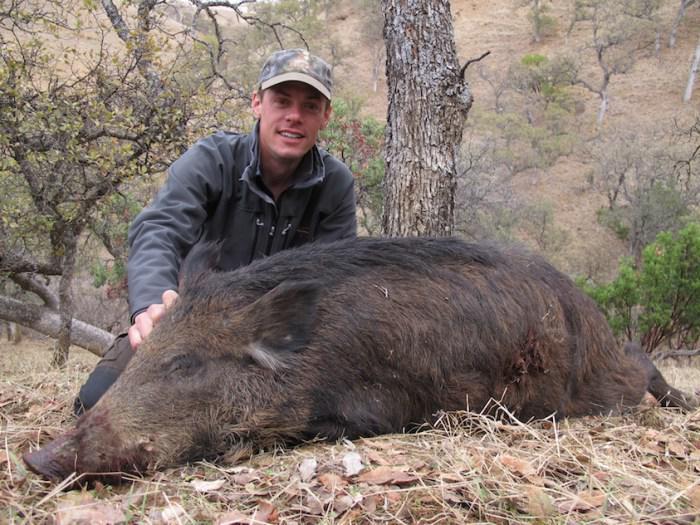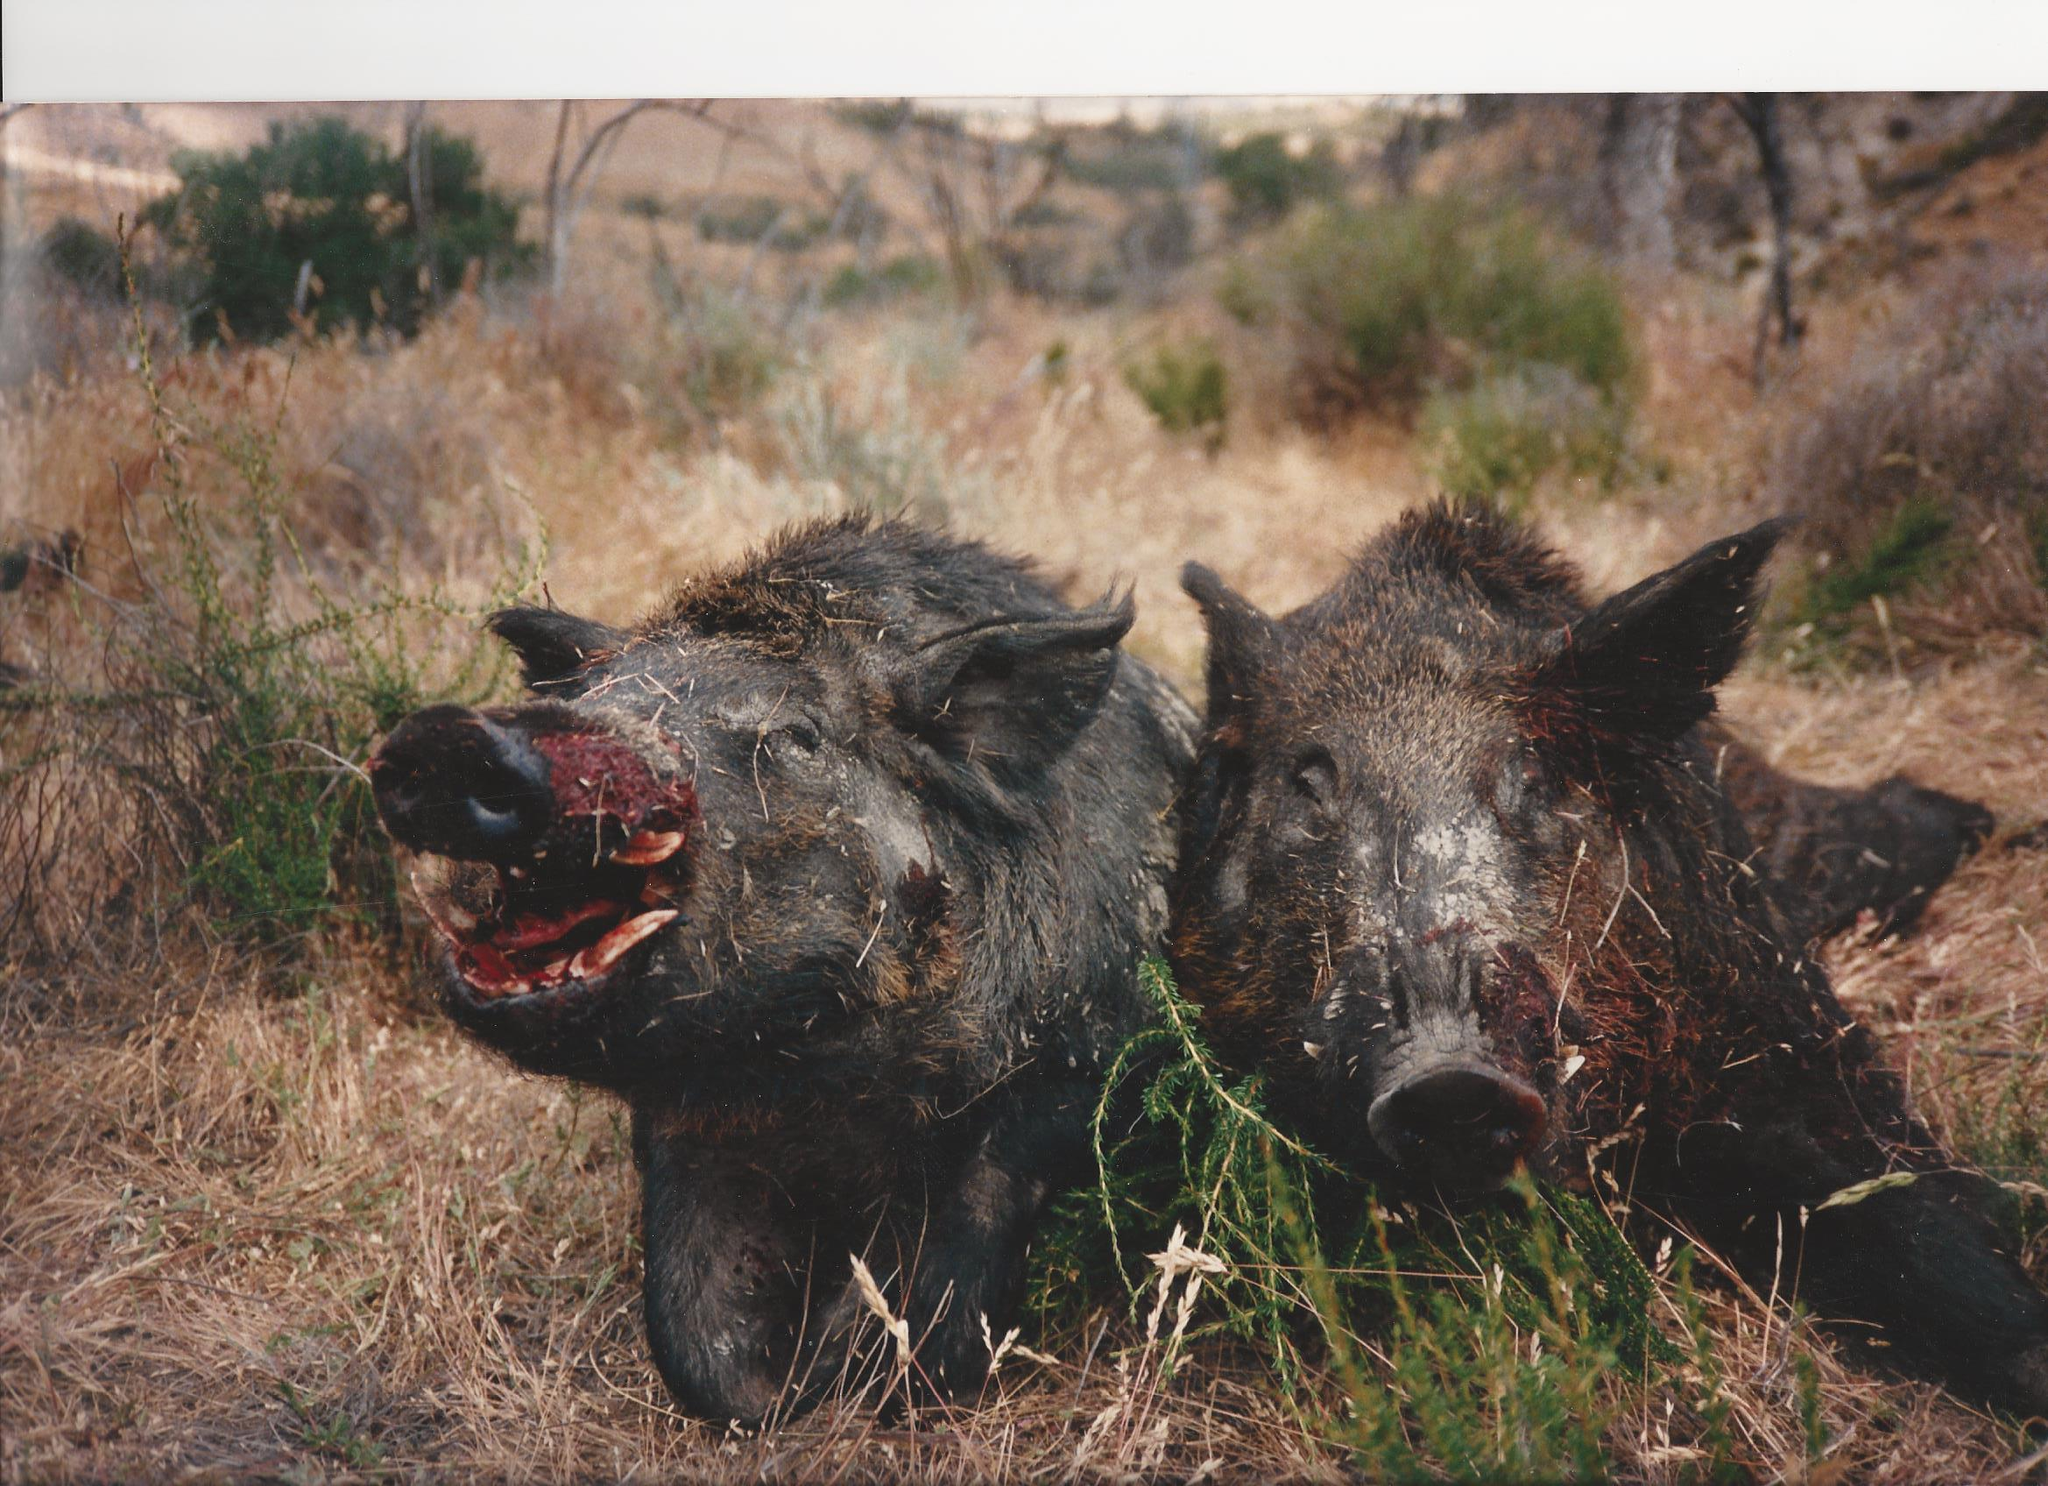The first image is the image on the left, the second image is the image on the right. For the images shown, is this caption "At least one image shows an animal fighting with the boar." true? Answer yes or no. No. The first image is the image on the left, the second image is the image on the right. For the images displayed, is the sentence "One of the image features one man next to a dead wild boar." factually correct? Answer yes or no. Yes. 